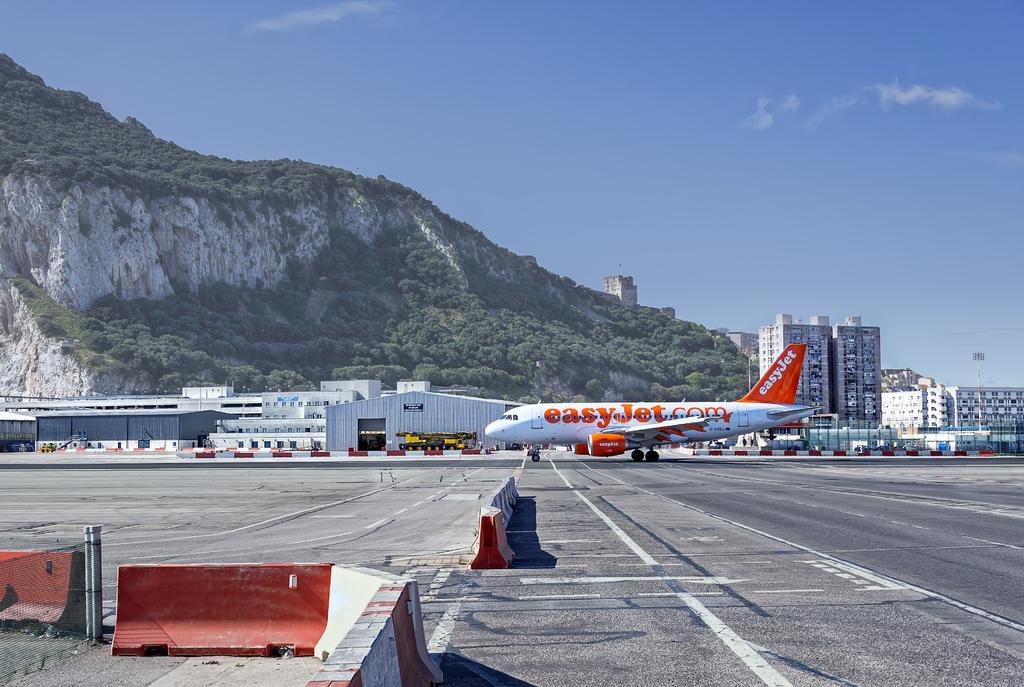Could you give a brief overview of what you see in this image? This is an airplane, which is on the runway. These are the buildings and sheds. This looks like a mountain. I can see the trees. This is the sky. I think these are the road dividers. 